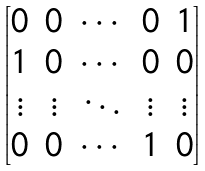Convert formula to latex. <formula><loc_0><loc_0><loc_500><loc_500>\begin{bmatrix} 0 & 0 & \cdots & 0 & 1 \\ 1 & 0 & \cdots & 0 & 0 \\ \vdots & \vdots & \ddots & \vdots & \vdots \\ 0 & 0 & \cdots & 1 & 0 \end{bmatrix}</formula> 